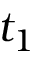Convert formula to latex. <formula><loc_0><loc_0><loc_500><loc_500>t _ { 1 }</formula> 